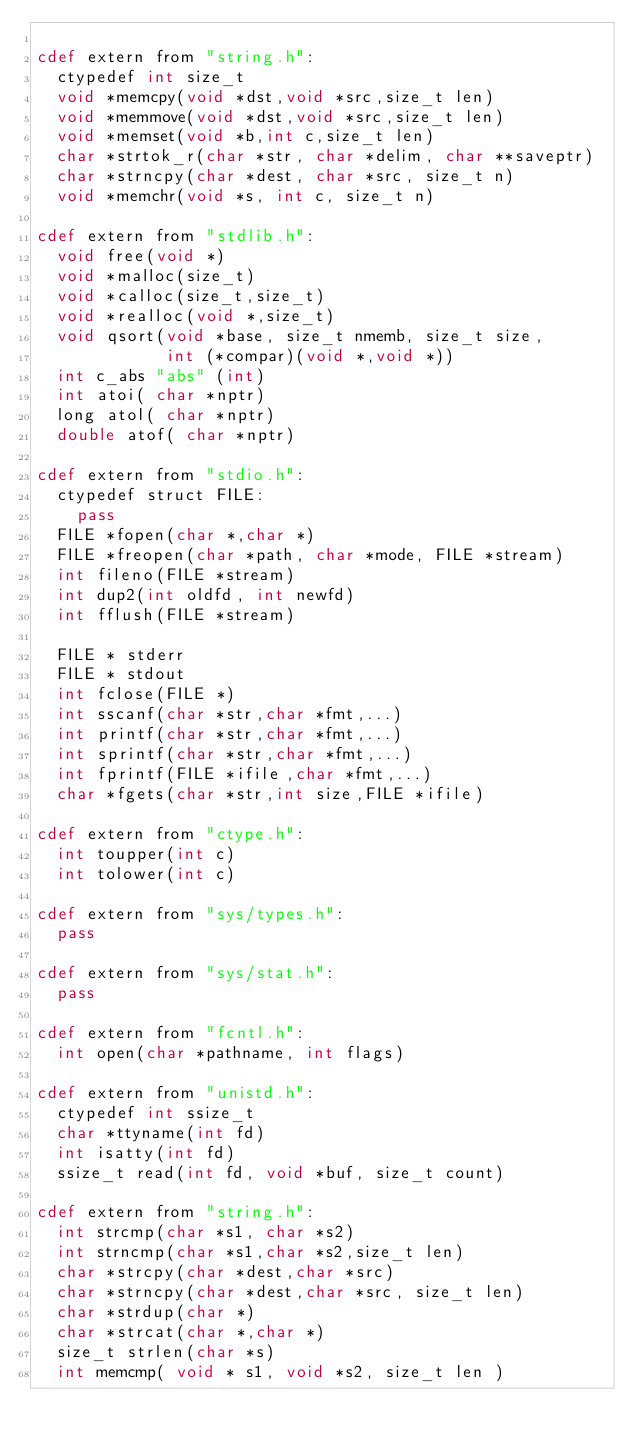<code> <loc_0><loc_0><loc_500><loc_500><_Cython_>
cdef extern from "string.h":
  ctypedef int size_t
  void *memcpy(void *dst,void *src,size_t len)
  void *memmove(void *dst,void *src,size_t len)
  void *memset(void *b,int c,size_t len)
  char *strtok_r(char *str, char *delim, char **saveptr)
  char *strncpy(char *dest, char *src, size_t n)
  void *memchr(void *s, int c, size_t n)

cdef extern from "stdlib.h":
  void free(void *)
  void *malloc(size_t)
  void *calloc(size_t,size_t)
  void *realloc(void *,size_t)
  void qsort(void *base, size_t nmemb, size_t size,
             int (*compar)(void *,void *))
  int c_abs "abs" (int)
  int atoi( char *nptr)
  long atol( char *nptr)
  double atof( char *nptr)

cdef extern from "stdio.h":
  ctypedef struct FILE:
    pass
  FILE *fopen(char *,char *)
  FILE *freopen(char *path, char *mode, FILE *stream)
  int fileno(FILE *stream)
  int dup2(int oldfd, int newfd)
  int fflush(FILE *stream)

  FILE * stderr
  FILE * stdout
  int fclose(FILE *)
  int sscanf(char *str,char *fmt,...)
  int printf(char *str,char *fmt,...)
  int sprintf(char *str,char *fmt,...)
  int fprintf(FILE *ifile,char *fmt,...)
  char *fgets(char *str,int size,FILE *ifile)

cdef extern from "ctype.h":
  int toupper(int c)
  int tolower(int c)

cdef extern from "sys/types.h":
  pass

cdef extern from "sys/stat.h":
  pass

cdef extern from "fcntl.h":
  int open(char *pathname, int flags)
  
cdef extern from "unistd.h":
  ctypedef int ssize_t
  char *ttyname(int fd)
  int isatty(int fd)  
  ssize_t read(int fd, void *buf, size_t count)

cdef extern from "string.h":
  int strcmp(char *s1, char *s2)
  int strncmp(char *s1,char *s2,size_t len)
  char *strcpy(char *dest,char *src)
  char *strncpy(char *dest,char *src, size_t len)
  char *strdup(char *)
  char *strcat(char *,char *)
  size_t strlen(char *s)
  int memcmp( void * s1, void *s2, size_t len )
</code> 